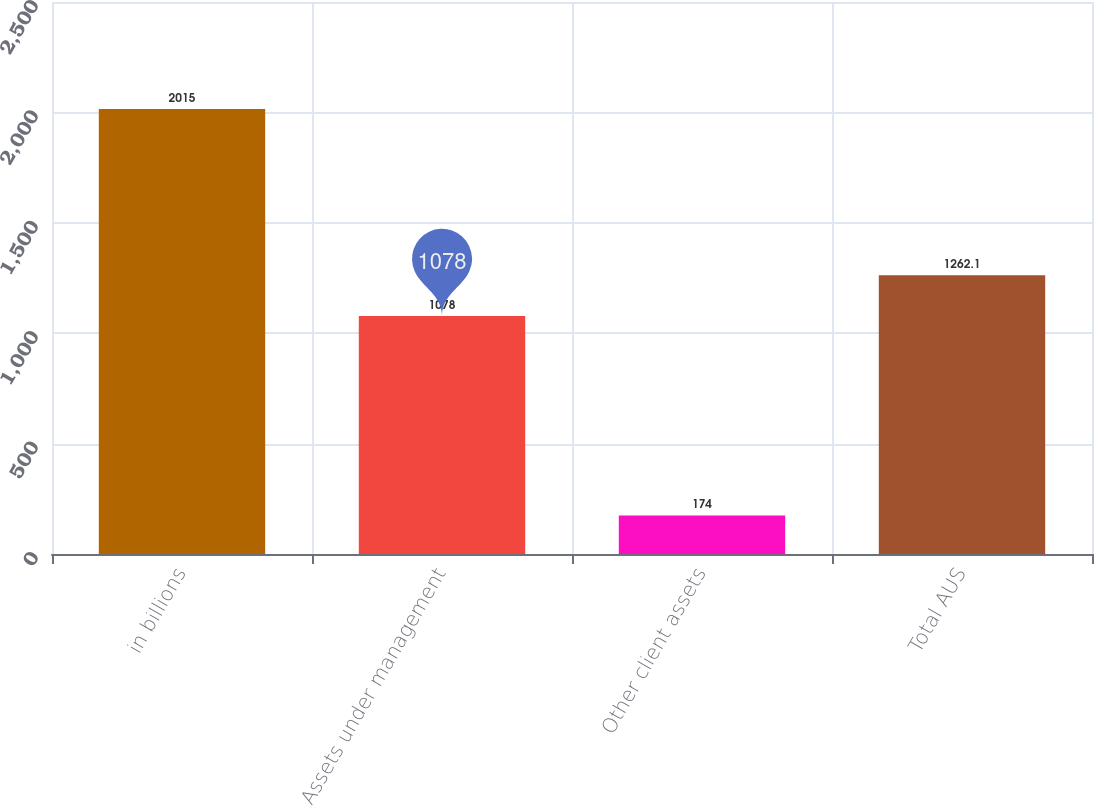Convert chart to OTSL. <chart><loc_0><loc_0><loc_500><loc_500><bar_chart><fcel>in billions<fcel>Assets under management<fcel>Other client assets<fcel>Total AUS<nl><fcel>2015<fcel>1078<fcel>174<fcel>1262.1<nl></chart> 